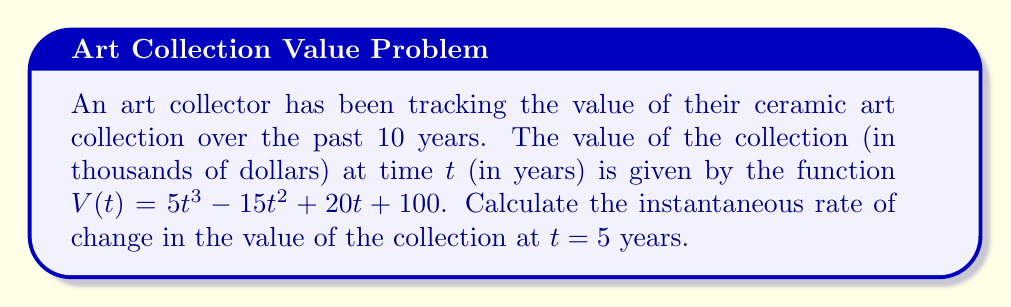Show me your answer to this math problem. To find the instantaneous rate of change at a specific point, we need to calculate the derivative of the function $V(t)$ and evaluate it at $t = 5$.

1. First, let's find the derivative of $V(t)$:
   
   $V(t) = 5t^3 - 15t^2 + 20t + 100$
   
   $V'(t) = 15t^2 - 30t + 20$

2. Now, we evaluate $V'(t)$ at $t = 5$:
   
   $V'(5) = 15(5)^2 - 30(5) + 20$
   
   $= 15(25) - 150 + 20$
   
   $= 375 - 150 + 20$
   
   $= 245$

3. Interpret the result:
   The value 245 represents the instantaneous rate of change in thousands of dollars per year. To convert this to dollars per year, we multiply by 1000.

   $245 \times 1000 = 245,000$

Therefore, at $t = 5$ years, the value of the ceramic art collection is increasing at a rate of $245,000 per year.
Answer: $245,000 per year 